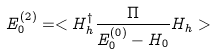<formula> <loc_0><loc_0><loc_500><loc_500>E _ { 0 } ^ { ( 2 ) } = < H _ { h } ^ { \dagger } \frac { \Pi } { E _ { 0 } ^ { ( 0 ) } - H _ { 0 } } H _ { h } ></formula> 